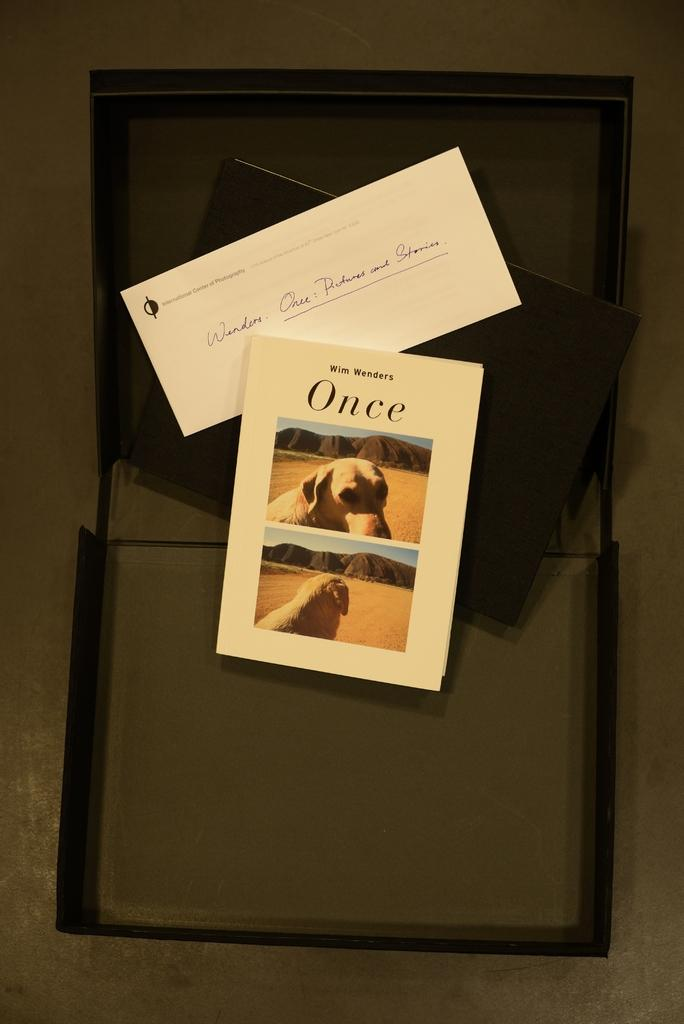What is displayed on the wall in the image? There are cards on a wall in the image. What do the cards depict? The cards depict dogs. What level of difficulty is indicated by the cards on the wall? The cards on the wall do not indicate a level of difficulty, as they are simply images of dogs. 